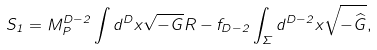Convert formula to latex. <formula><loc_0><loc_0><loc_500><loc_500>S _ { 1 } = M _ { P } ^ { D - 2 } \int d ^ { D } x \sqrt { - G } R - f _ { D - 2 } \int _ { \Sigma } d ^ { D - 2 } x \sqrt { - { \widehat { G } } } ,</formula> 